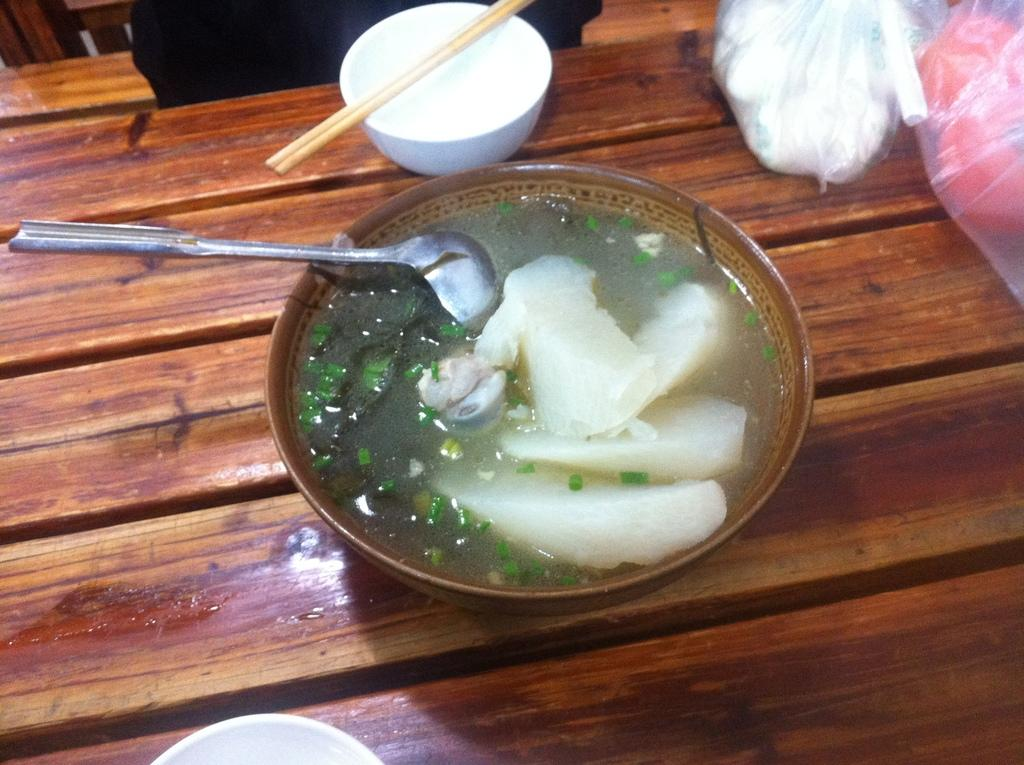What piece of furniture is in the image? There is a table in the image. What is on top of the table? There is a bowl, chopsticks, a spoon, a food item in a dish, and plastic covers on the table. What utensils are present on the table? Chopsticks and a spoon are present on the table. What type of food item is in a dish on the table? The food item in a dish on the table is not specified, but it is present. What is the title of the vessel in the image? There is no vessel present in the image, and therefore no title can be assigned. 